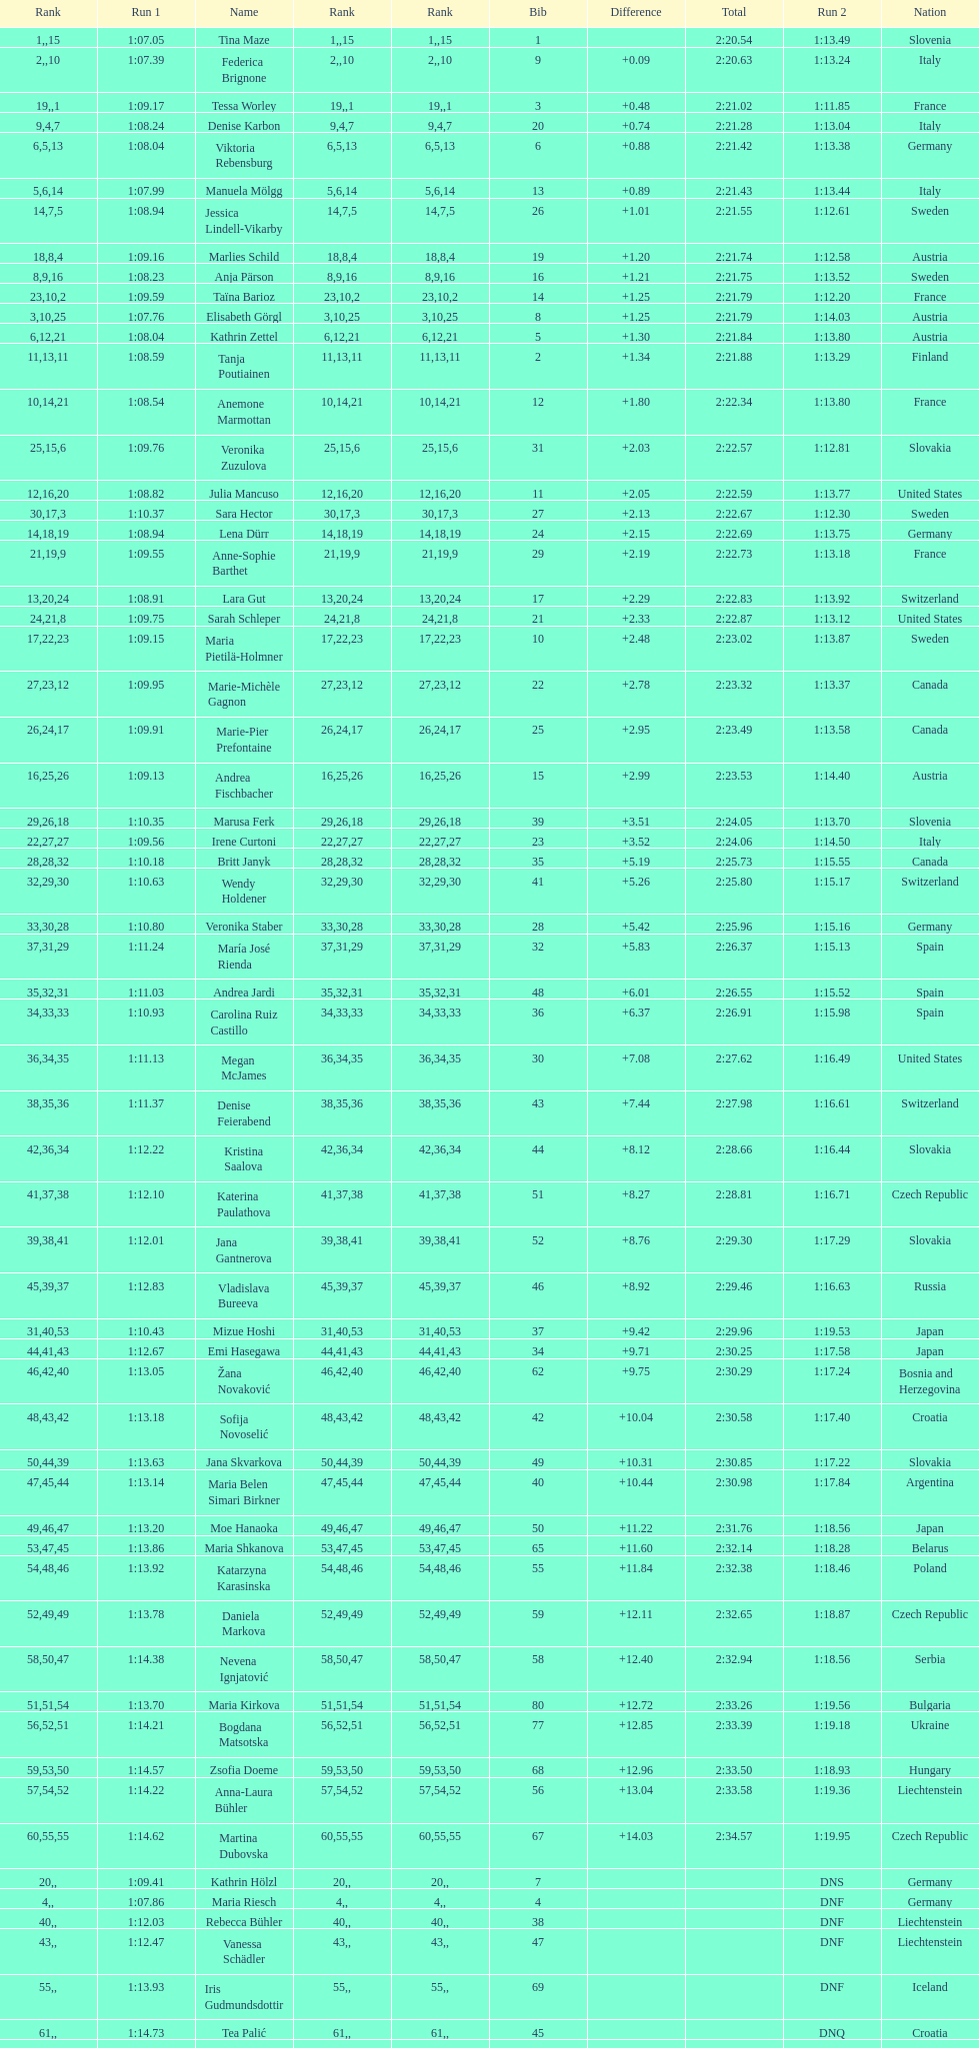Who finished next after federica brignone? Tessa Worley. 